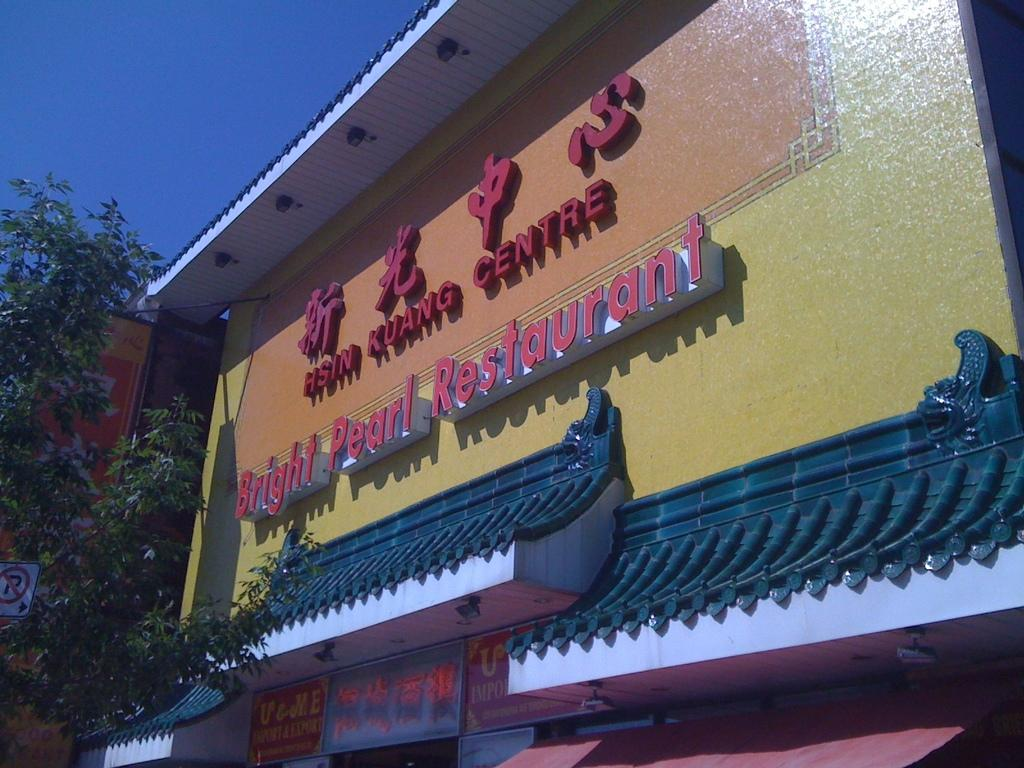<image>
Create a compact narrative representing the image presented. a title above the awning that says Bright Pearl Restaurant 